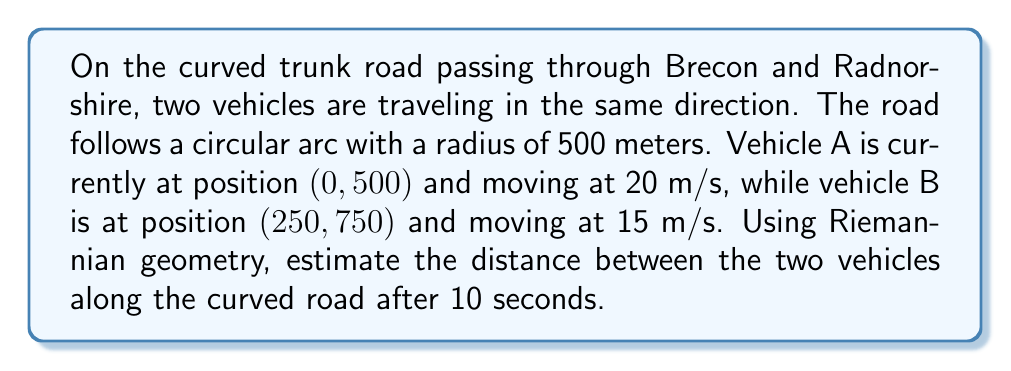Can you answer this question? To solve this problem, we'll use Riemannian geometry to calculate the geodesic distance along the curved road. Here's a step-by-step approach:

1. Define the metric tensor for the circular road:
   The metric tensor in polar coordinates $(r, \theta)$ is:
   $$g = \begin{pmatrix} 1 & 0 \\ 0 & r^2 \end{pmatrix}$$

2. Convert the given Cartesian coordinates to polar coordinates:
   For vehicle A: $(0, 500) \rightarrow (r_A = 500, \theta_A = \pi/2)$
   For vehicle B: $(250, 750) \rightarrow (r_B = 500, \theta_B = \arctan(3) \approx 1.2490)$

3. Calculate the angular velocities:
   $\omega_A = \frac{v_A}{r} = \frac{20}{500} = 0.04$ rad/s
   $\omega_B = \frac{v_B}{r} = \frac{15}{500} = 0.03$ rad/s

4. Calculate the new angular positions after 10 seconds:
   $\theta_A' = \theta_A + \omega_A t = \frac{\pi}{2} + 0.04 \cdot 10 = 1.9708$ rad
   $\theta_B' = \theta_B + \omega_B t = 1.2490 + 0.03 \cdot 10 = 1.5490$ rad

5. Calculate the angular difference:
   $\Delta \theta = \theta_A' - \theta_B' = 1.9708 - 1.5490 = 0.4218$ rad

6. Use the Riemannian distance formula for a circular arc:
   $$s = r \Delta \theta = 500 \cdot 0.4218 = 210.9$$

Therefore, the estimated distance between the two vehicles along the curved road after 10 seconds is approximately 210.9 meters.
Answer: 210.9 meters 